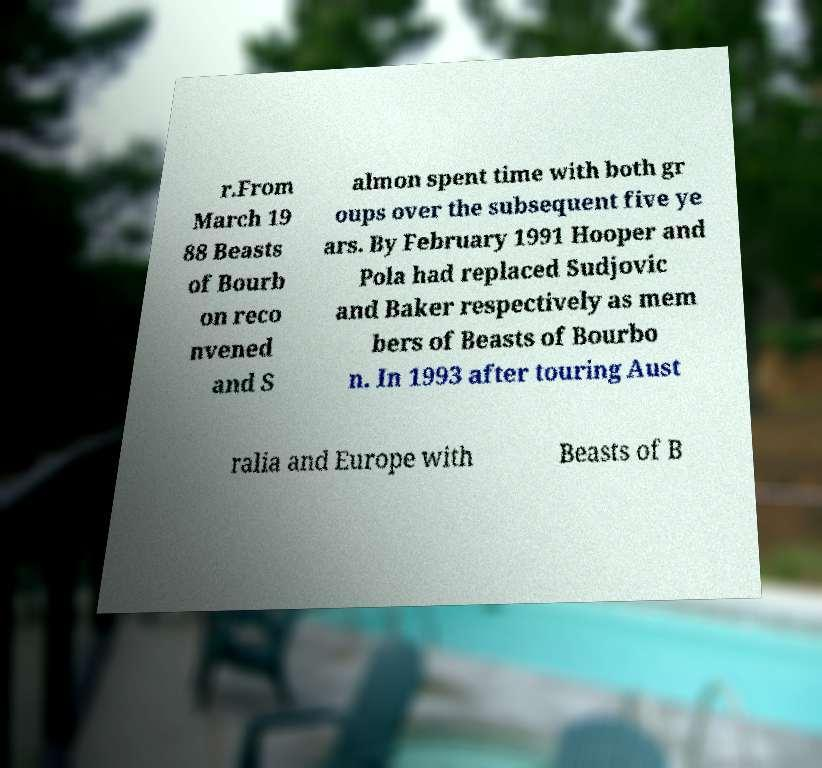Please identify and transcribe the text found in this image. r.From March 19 88 Beasts of Bourb on reco nvened and S almon spent time with both gr oups over the subsequent five ye ars. By February 1991 Hooper and Pola had replaced Sudjovic and Baker respectively as mem bers of Beasts of Bourbo n. In 1993 after touring Aust ralia and Europe with Beasts of B 